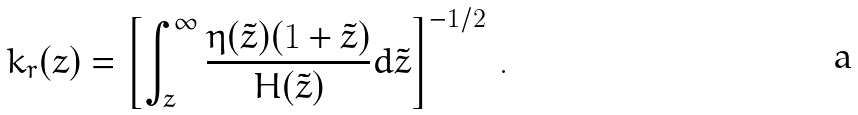<formula> <loc_0><loc_0><loc_500><loc_500>k _ { r } ( z ) = \left [ \int _ { z } ^ { \infty } \frac { \eta ( \tilde { z } ) ( 1 + \tilde { z } ) } { H ( \tilde { z } ) } d \tilde { z } \right ] ^ { - 1 / 2 } \, .</formula> 